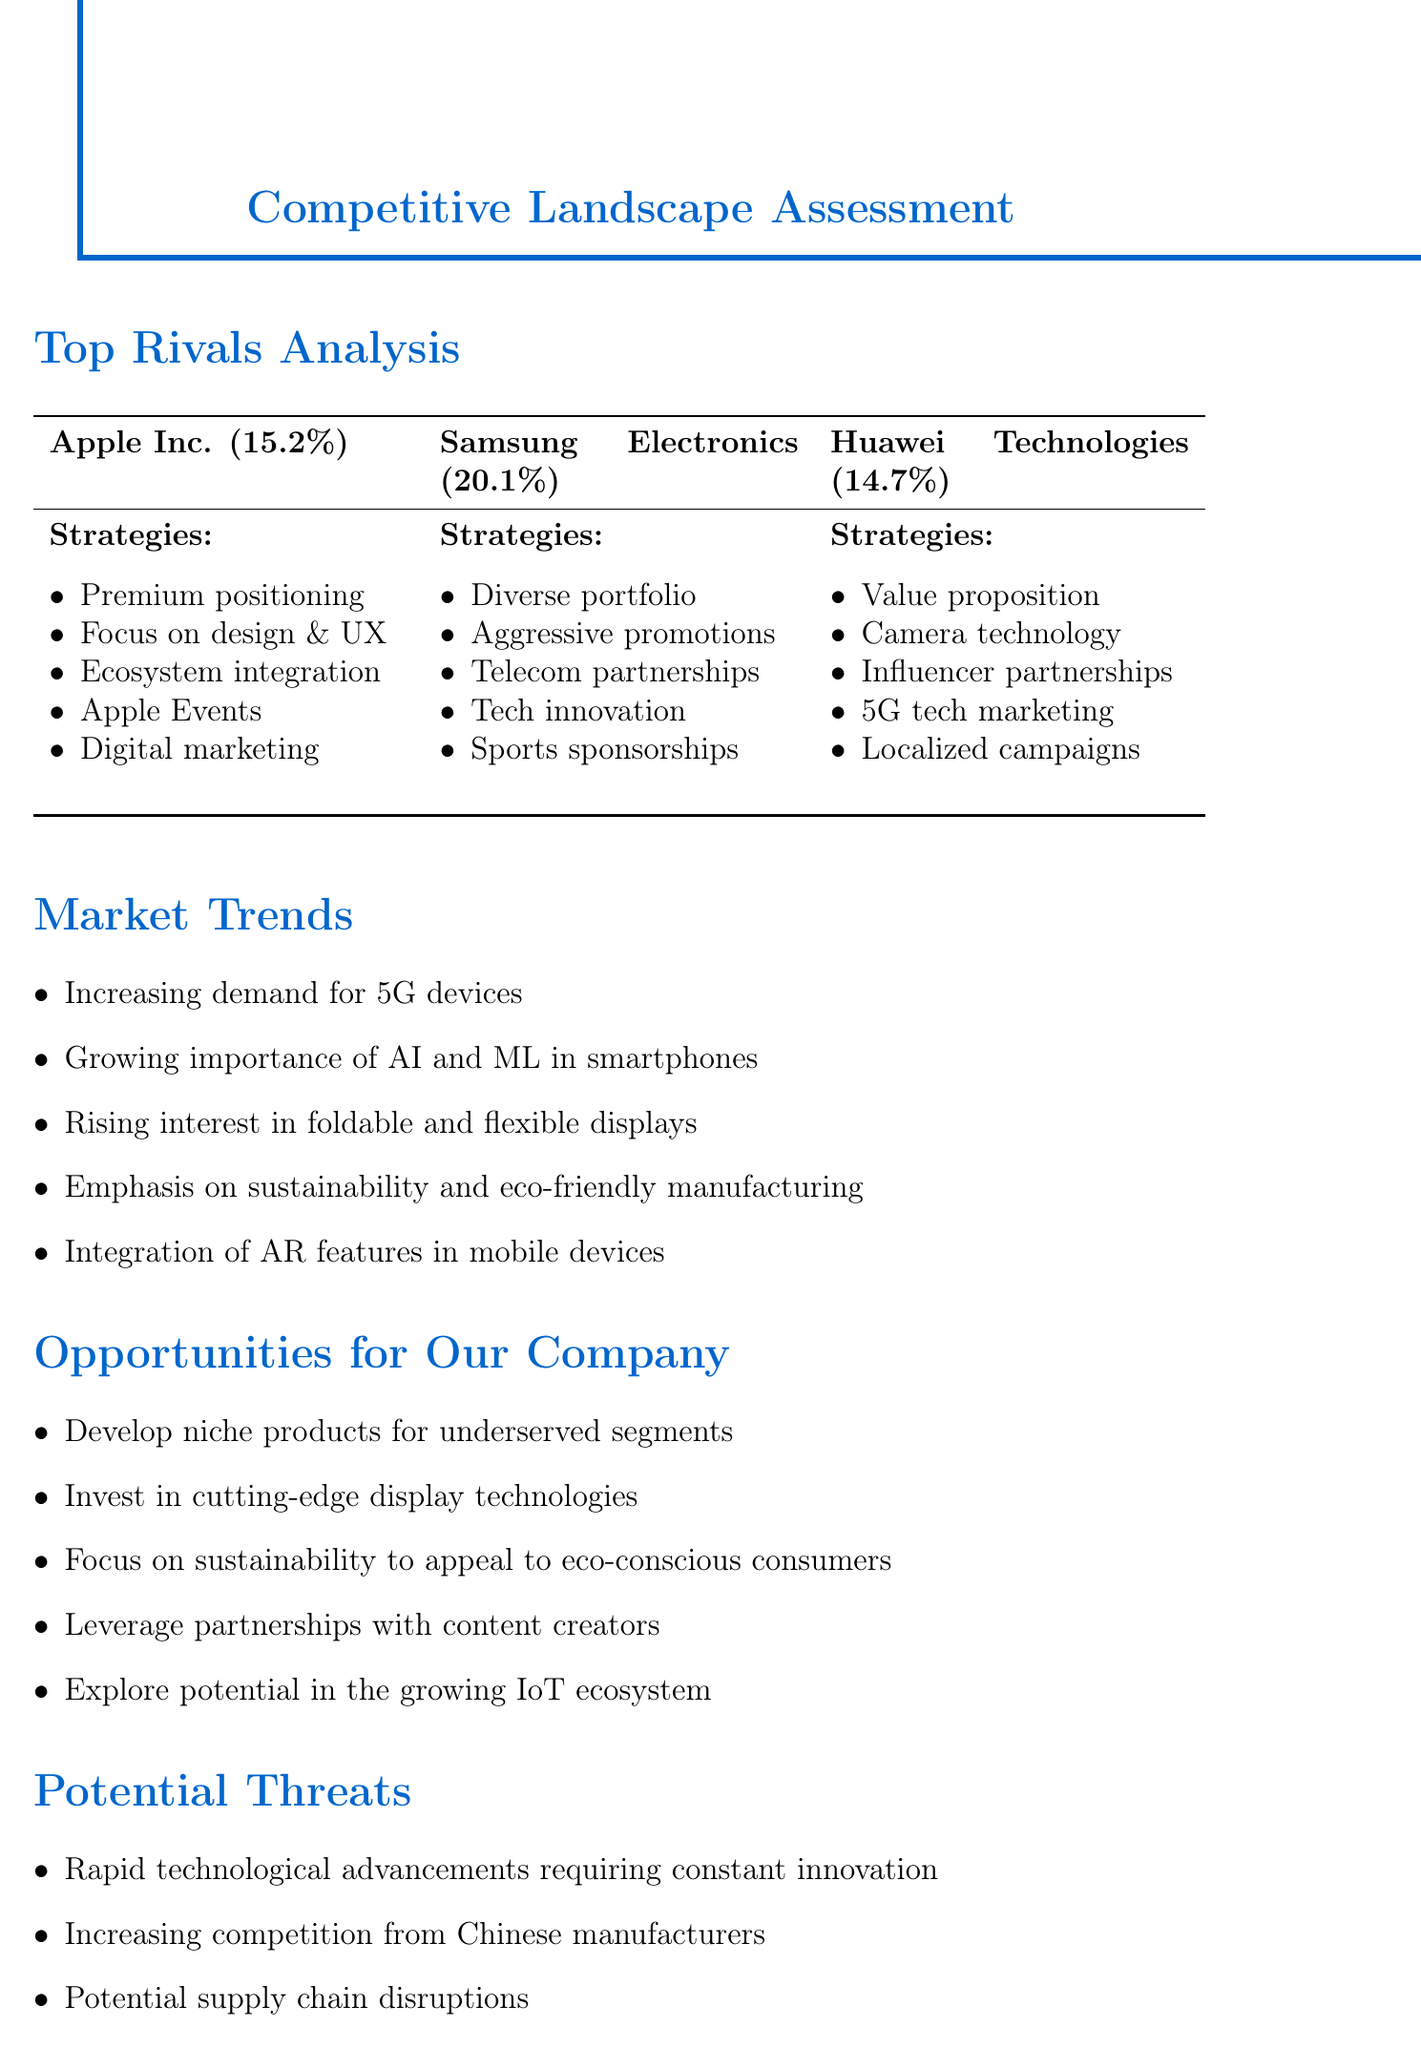What is the market share of Apple Inc.? The market share of Apple Inc. is specifically stated in the document as 15.2%.
Answer: 15.2% What is Samsung's primary marketing strategy? Samsung's primary marketing strategy includes aggressive promotional campaigns, which is highlighted alongside other strategies in the document.
Answer: Aggressive promotional campaigns What percentage of the market does Huawei Technologies hold? Huawei Technologies' market share is directly mentioned in the document, which is 14.7%.
Answer: 14.7% What is a weakness of Apple Inc.? The document lists several weaknesses of Apple Inc., including its higher price points as a significant weakness.
Answer: Higher price points Which company focuses on camera technology in its marketing strategies? The document specifies that Huawei Technologies emphasizes camera technology as part of its marketing strategies.
Answer: Huawei Technologies What is one opportunity for our company mentioned in the document? One of the opportunities mentioned for our company is to develop niche products for underserved market segments.
Answer: Develop niche products for underserved segments How does Samsung integrate its technology? The document states that Samsung focuses on technological innovation as a key part of its marketing strategies.
Answer: Technological innovation What is a potential threat mentioned in the document? One of the potential threats detailed in the document is rapid technological advancements requiring constant innovation.
Answer: Rapid technological advancements What market trend relates to consumer devices? The increasing demand for 5G-enabled devices is highlighted as a key market trend in the document.
Answer: Increasing demand for 5G-enabled devices 